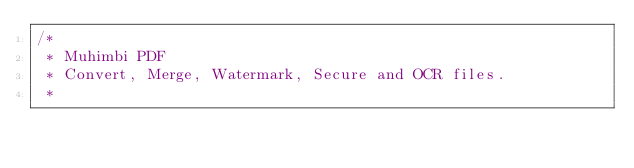Convert code to text. <code><loc_0><loc_0><loc_500><loc_500><_Java_>/*
 * Muhimbi PDF
 * Convert, Merge, Watermark, Secure and OCR files.
 *</code> 